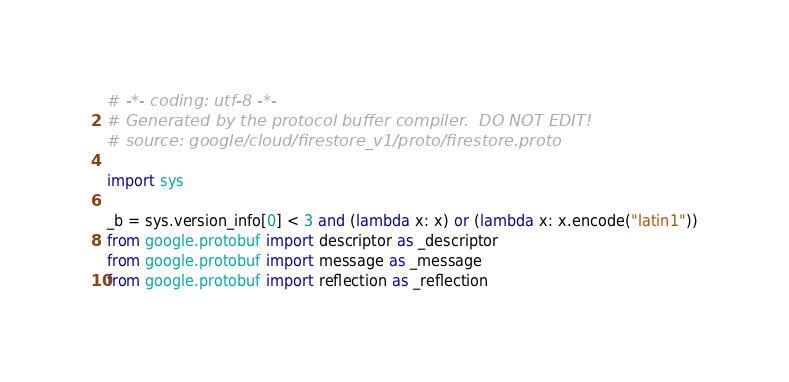<code> <loc_0><loc_0><loc_500><loc_500><_Python_># -*- coding: utf-8 -*-
# Generated by the protocol buffer compiler.  DO NOT EDIT!
# source: google/cloud/firestore_v1/proto/firestore.proto

import sys

_b = sys.version_info[0] < 3 and (lambda x: x) or (lambda x: x.encode("latin1"))
from google.protobuf import descriptor as _descriptor
from google.protobuf import message as _message
from google.protobuf import reflection as _reflection</code> 